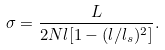<formula> <loc_0><loc_0><loc_500><loc_500>\sigma = \frac { L } { 2 N l [ 1 - ( l / l _ { s } ) ^ { 2 } ] } .</formula> 